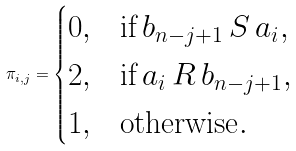<formula> <loc_0><loc_0><loc_500><loc_500>\pi _ { i , j } = \begin{cases} 0 , & \text {if} \, b _ { n - j + 1 } \, S \, a _ { i } , \\ 2 , & \text {if} \, a _ { i } \, R \, b _ { n - j + 1 } , \\ 1 , & \text {otherwise} . \end{cases}</formula> 